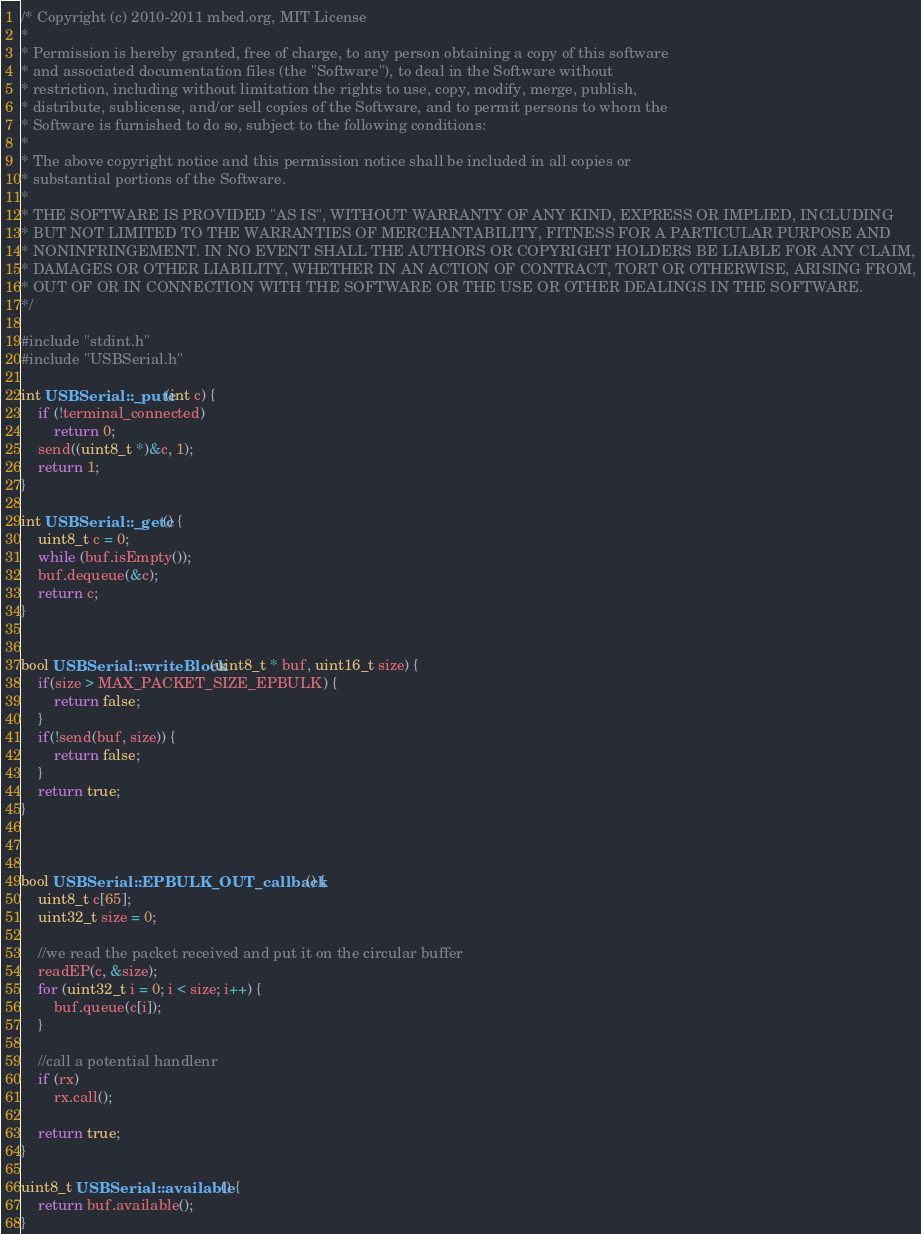Convert code to text. <code><loc_0><loc_0><loc_500><loc_500><_C++_>/* Copyright (c) 2010-2011 mbed.org, MIT License
*
* Permission is hereby granted, free of charge, to any person obtaining a copy of this software
* and associated documentation files (the "Software"), to deal in the Software without
* restriction, including without limitation the rights to use, copy, modify, merge, publish,
* distribute, sublicense, and/or sell copies of the Software, and to permit persons to whom the
* Software is furnished to do so, subject to the following conditions:
*
* The above copyright notice and this permission notice shall be included in all copies or
* substantial portions of the Software.
*
* THE SOFTWARE IS PROVIDED "AS IS", WITHOUT WARRANTY OF ANY KIND, EXPRESS OR IMPLIED, INCLUDING
* BUT NOT LIMITED TO THE WARRANTIES OF MERCHANTABILITY, FITNESS FOR A PARTICULAR PURPOSE AND
* NONINFRINGEMENT. IN NO EVENT SHALL THE AUTHORS OR COPYRIGHT HOLDERS BE LIABLE FOR ANY CLAIM,
* DAMAGES OR OTHER LIABILITY, WHETHER IN AN ACTION OF CONTRACT, TORT OR OTHERWISE, ARISING FROM,
* OUT OF OR IN CONNECTION WITH THE SOFTWARE OR THE USE OR OTHER DEALINGS IN THE SOFTWARE.
*/

#include "stdint.h"
#include "USBSerial.h"

int USBSerial::_putc(int c) {
    if (!terminal_connected)
        return 0;
    send((uint8_t *)&c, 1);
    return 1;
}

int USBSerial::_getc() {
    uint8_t c = 0;
    while (buf.isEmpty());
    buf.dequeue(&c);
    return c;
}


bool USBSerial::writeBlock(uint8_t * buf, uint16_t size) {
    if(size > MAX_PACKET_SIZE_EPBULK) {
        return false;
    }
    if(!send(buf, size)) {
        return false;
    }
    return true;
}



bool USBSerial::EPBULK_OUT_callback() {
    uint8_t c[65];
    uint32_t size = 0;

    //we read the packet received and put it on the circular buffer
    readEP(c, &size);
    for (uint32_t i = 0; i < size; i++) {
        buf.queue(c[i]);
    }

    //call a potential handlenr
    if (rx)
        rx.call();

    return true;
}

uint8_t USBSerial::available() {
    return buf.available();
}
</code> 